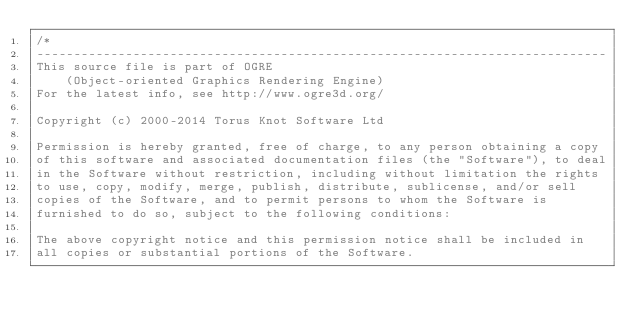<code> <loc_0><loc_0><loc_500><loc_500><_C_>/*
-----------------------------------------------------------------------------
This source file is part of OGRE
    (Object-oriented Graphics Rendering Engine)
For the latest info, see http://www.ogre3d.org/

Copyright (c) 2000-2014 Torus Knot Software Ltd

Permission is hereby granted, free of charge, to any person obtaining a copy
of this software and associated documentation files (the "Software"), to deal
in the Software without restriction, including without limitation the rights
to use, copy, modify, merge, publish, distribute, sublicense, and/or sell
copies of the Software, and to permit persons to whom the Software is
furnished to do so, subject to the following conditions:

The above copyright notice and this permission notice shall be included in
all copies or substantial portions of the Software.
</code> 